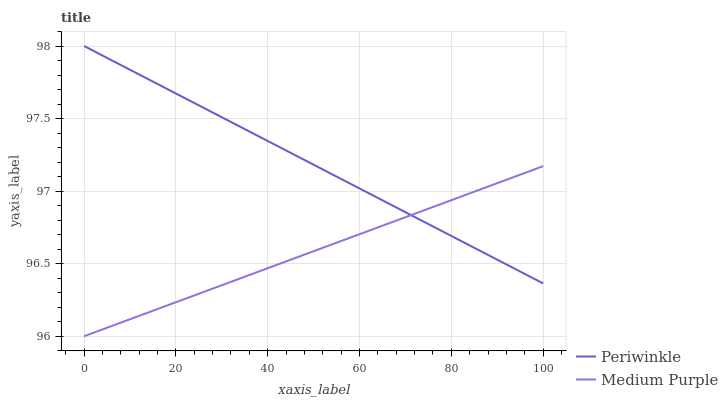Does Periwinkle have the minimum area under the curve?
Answer yes or no. No. Is Periwinkle the roughest?
Answer yes or no. No. Does Periwinkle have the lowest value?
Answer yes or no. No. 